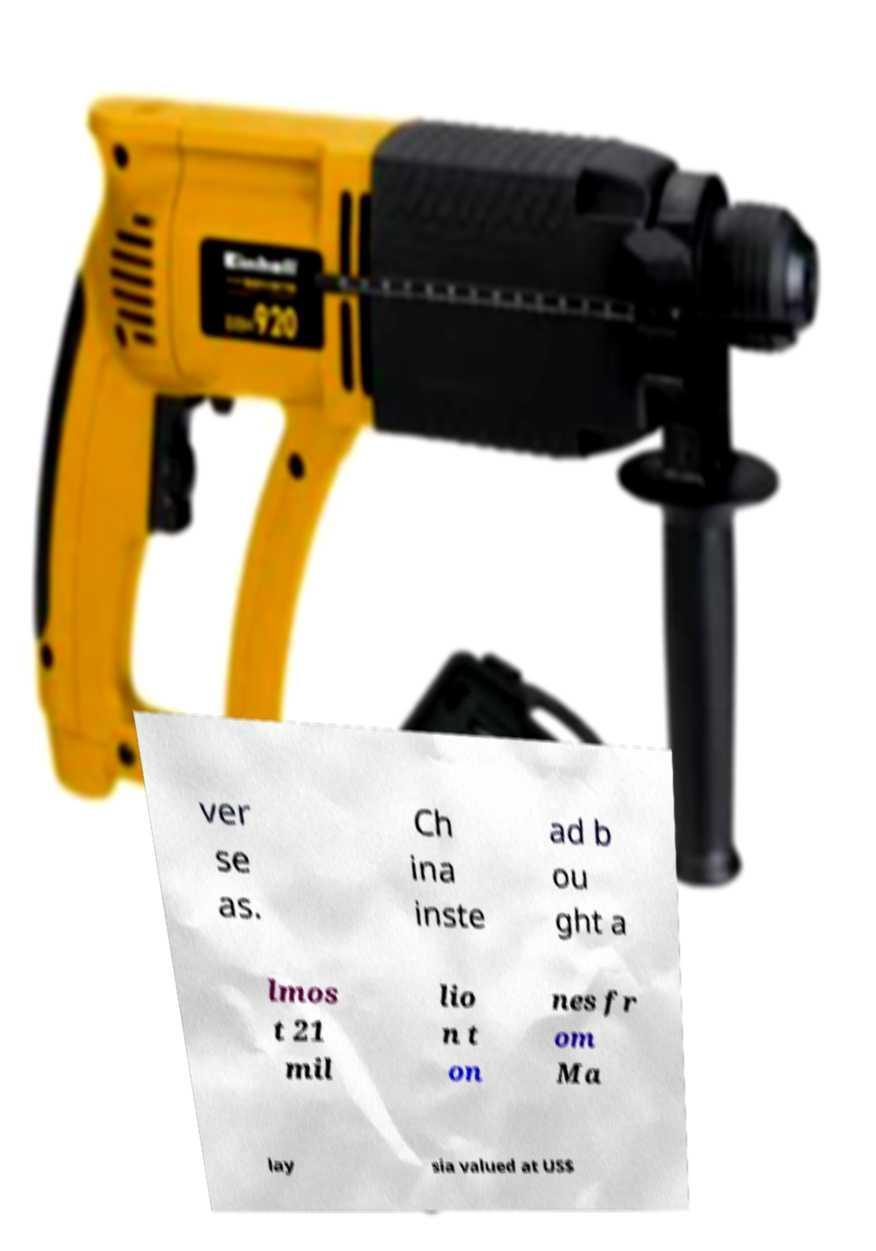Could you extract and type out the text from this image? ver se as. Ch ina inste ad b ou ght a lmos t 21 mil lio n t on nes fr om Ma lay sia valued at US$ 